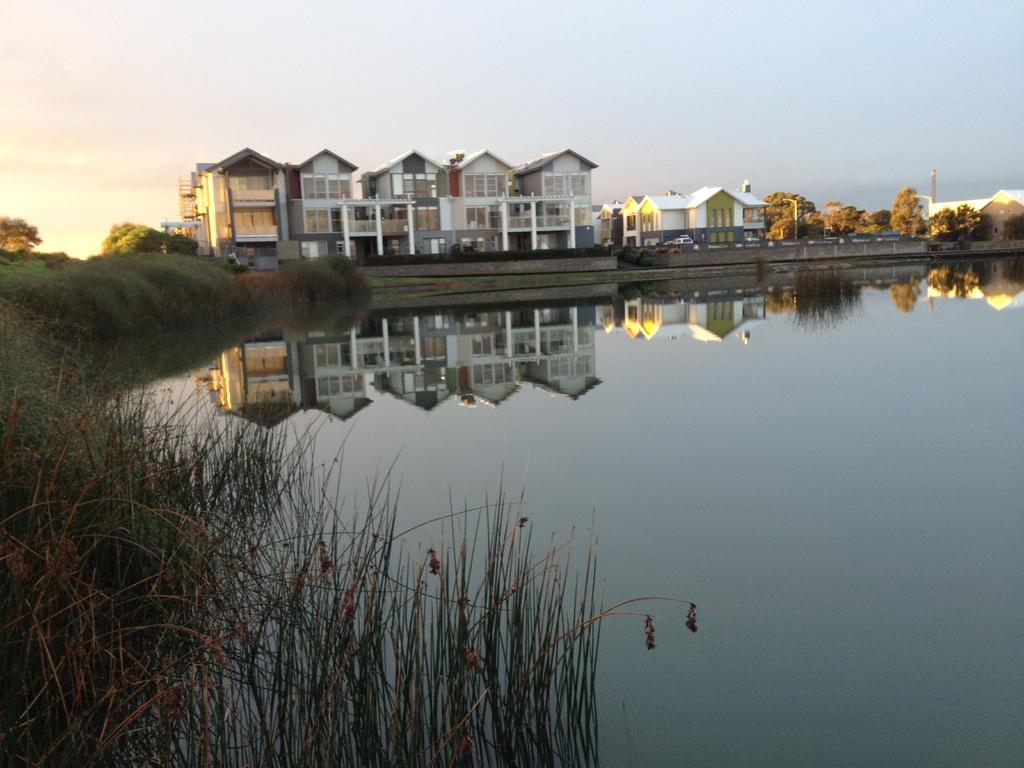What can be seen in the foreground of the picture? There is grass, weed, and water in the foreground of the picture. What is located in the center of the picture? There are trees, buildings, vehicles, and poles in the center of the picture. What is the condition of the sky in the picture? The sky is clear in the picture. What type of pancake is being served on the pole in the center of the picture? There is no pancake present in the image, and no pancakes are being served on any poles. What color are the trousers worn by the trees in the center of the picture? Trees do not wear trousers, as they are living organisms and not people. --- Facts: 1. There is a person sitting on a chair in the image. 2. The person is holding a book. 3. The book has a blue cover. 4. There is a table next to the chair. 5. There is a lamp on the table. 6. The background of the image is a wall. Absurd Topics: elephant, ocean, bicycle Conversation: What is the person in the image doing? The person is sitting on a chair in the image. What is the person holding in the image? The person is holding a book in the image. What color is the book's cover? The book has a blue cover. What is located next to the chair in the image? There is a table next to the chair in the image. What is on the table in the image? There is a lamp on the table in the image. Reasoning: Let's think step by step in order to produce the conversation. We start by identifying the main subject in the image, which is the person sitting on a chair. Then, we expand the conversation to include other items that are also visible, such as the book, the table, the lamp, and the wall. Each question is designed to elicit a specific detail about the image that is known from the provided facts. Absurd Question/Answer: Can you see an elephant swimming in the ocean in the background of the image? There is no elephant or ocean present in the image; the background is a wall. Is there a bicycle leaning against the wall in the background of the image? There is no bicycle present in the image; the background is a wall. 